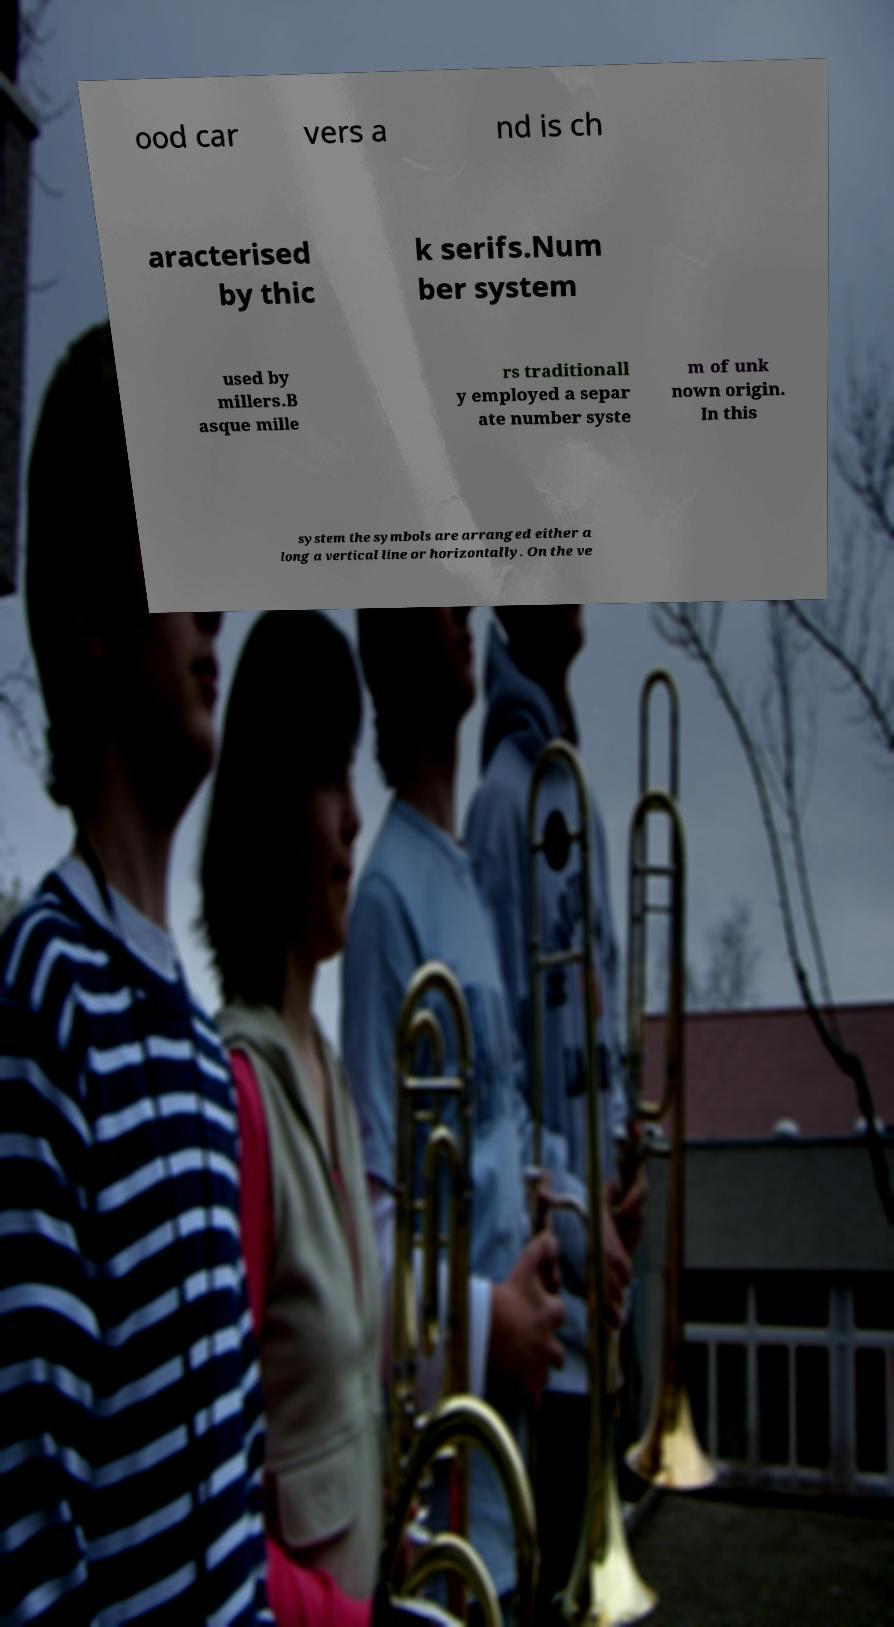For documentation purposes, I need the text within this image transcribed. Could you provide that? ood car vers a nd is ch aracterised by thic k serifs.Num ber system used by millers.B asque mille rs traditionall y employed a separ ate number syste m of unk nown origin. In this system the symbols are arranged either a long a vertical line or horizontally. On the ve 